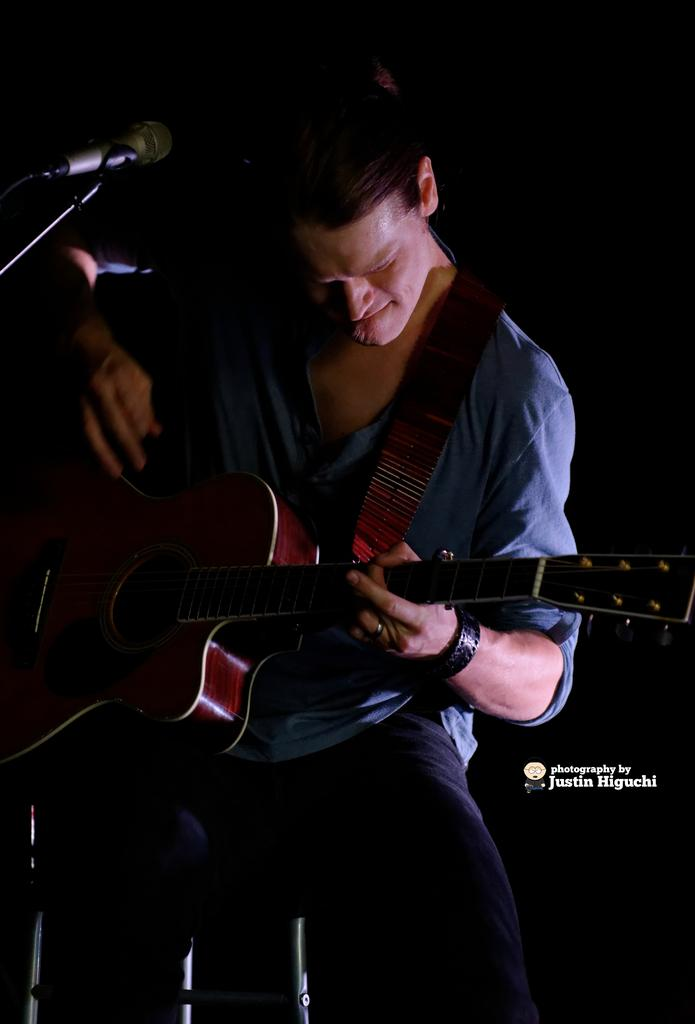What is the man in the image holding? The man is holding a guitar. What object is in front of the man? There is a microphone in front of the man. What might the man be doing in the image? The man might be playing the guitar and singing into the microphone. What type of berry is the man holding in the image? There is no berry present in the image; the man is holding a guitar. What color is the gold object the man is playing with in the image? There is no gold object present in the image; the man is holding a guitar. 